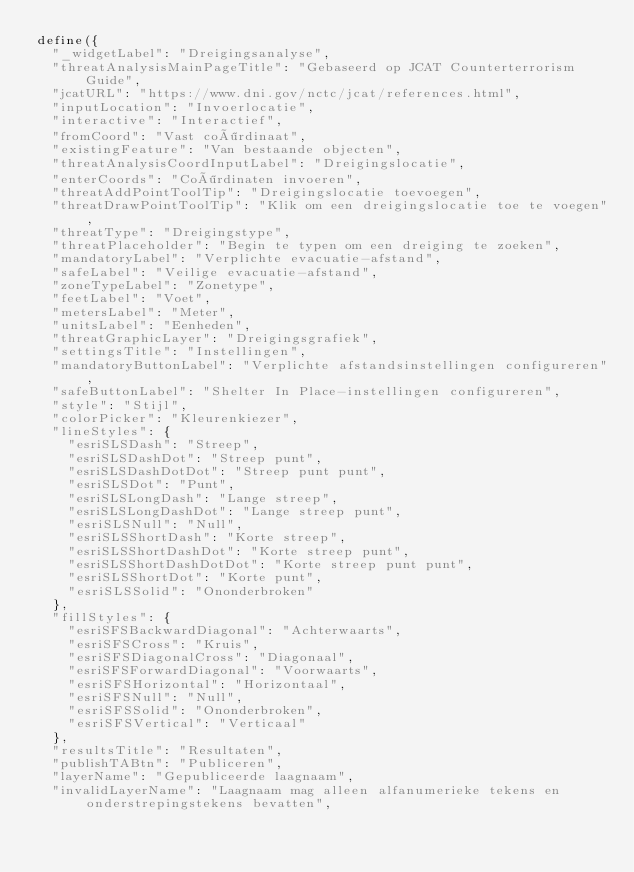Convert code to text. <code><loc_0><loc_0><loc_500><loc_500><_JavaScript_>define({
  "_widgetLabel": "Dreigingsanalyse",
  "threatAnalysisMainPageTitle": "Gebaseerd op JCAT Counterterrorism Guide",
  "jcatURL": "https://www.dni.gov/nctc/jcat/references.html",
  "inputLocation": "Invoerlocatie",
  "interactive": "Interactief",
  "fromCoord": "Vast coördinaat",
  "existingFeature": "Van bestaande objecten",
  "threatAnalysisCoordInputLabel": "Dreigingslocatie",
  "enterCoords": "Coördinaten invoeren",
  "threatAddPointToolTip": "Dreigingslocatie toevoegen",
  "threatDrawPointToolTip": "Klik om een dreigingslocatie toe te voegen",
  "threatType": "Dreigingstype",
  "threatPlaceholder": "Begin te typen om een dreiging te zoeken",
  "mandatoryLabel": "Verplichte evacuatie-afstand",
  "safeLabel": "Veilige evacuatie-afstand",
  "zoneTypeLabel": "Zonetype",
  "feetLabel": "Voet",
  "metersLabel": "Meter",
  "unitsLabel": "Eenheden",
  "threatGraphicLayer": "Dreigingsgrafiek",
  "settingsTitle": "Instellingen",
  "mandatoryButtonLabel": "Verplichte afstandsinstellingen configureren",
  "safeButtonLabel": "Shelter In Place-instellingen configureren",
  "style": "Stijl",
  "colorPicker": "Kleurenkiezer",
  "lineStyles": {
    "esriSLSDash": "Streep",
    "esriSLSDashDot": "Streep punt",
    "esriSLSDashDotDot": "Streep punt punt",
    "esriSLSDot": "Punt",
    "esriSLSLongDash": "Lange streep",
    "esriSLSLongDashDot": "Lange streep punt",
    "esriSLSNull": "Null",
    "esriSLSShortDash": "Korte streep",
    "esriSLSShortDashDot": "Korte streep punt",
    "esriSLSShortDashDotDot": "Korte streep punt punt",
    "esriSLSShortDot": "Korte punt",
    "esriSLSSolid": "Ononderbroken"
  },
  "fillStyles": {
    "esriSFSBackwardDiagonal": "Achterwaarts",
    "esriSFSCross": "Kruis",
    "esriSFSDiagonalCross": "Diagonaal",
    "esriSFSForwardDiagonal": "Voorwaarts",
    "esriSFSHorizontal": "Horizontaal",
    "esriSFSNull": "Null",
    "esriSFSSolid": "Ononderbroken",
    "esriSFSVertical": "Verticaal"
  },
  "resultsTitle": "Resultaten",
  "publishTABtn": "Publiceren",
  "layerName": "Gepubliceerde laagnaam",
  "invalidLayerName": "Laagnaam mag alleen alfanumerieke tekens en onderstrepingstekens bevatten",</code> 